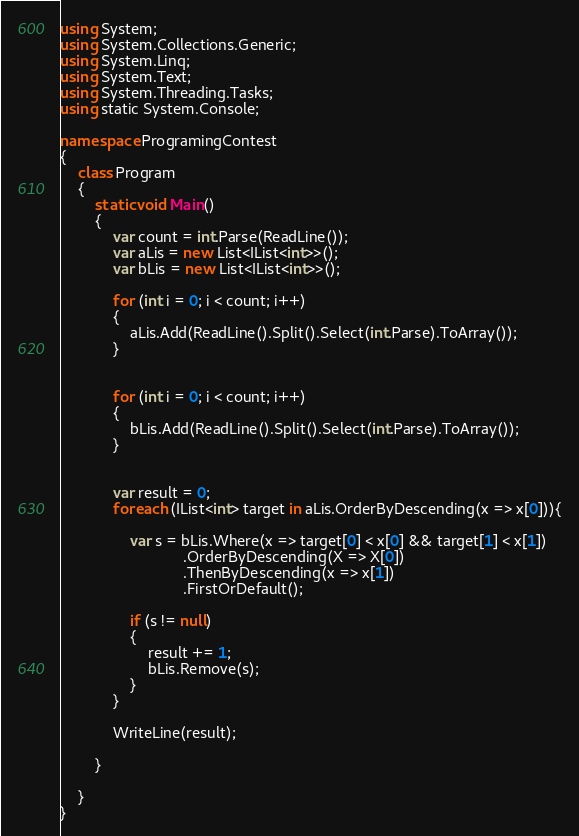Convert code to text. <code><loc_0><loc_0><loc_500><loc_500><_C#_>
using System;
using System.Collections.Generic;
using System.Linq;
using System.Text;
using System.Threading.Tasks;
using static System.Console;

namespace ProgramingContest
{
    class Program
    {
        static void Main()
        {
            var count = int.Parse(ReadLine());
            var aLis = new List<IList<int>>();
            var bLis = new List<IList<int>>();

            for (int i = 0; i < count; i++)
            {
                aLis.Add(ReadLine().Split().Select(int.Parse).ToArray());
            }


            for (int i = 0; i < count; i++)
            {
                bLis.Add(ReadLine().Split().Select(int.Parse).ToArray());
            }


            var result = 0;
            foreach (IList<int> target in aLis.OrderByDescending(x => x[0])){

                var s = bLis.Where(x => target[0] < x[0] && target[1] < x[1])
                            .OrderByDescending(X => X[0])
                            .ThenByDescending(x => x[1])
                            .FirstOrDefault();

                if (s != null)
                {
                    result += 1;
                    bLis.Remove(s);
                }
            }

            WriteLine(result);

        }

    }
}
</code> 